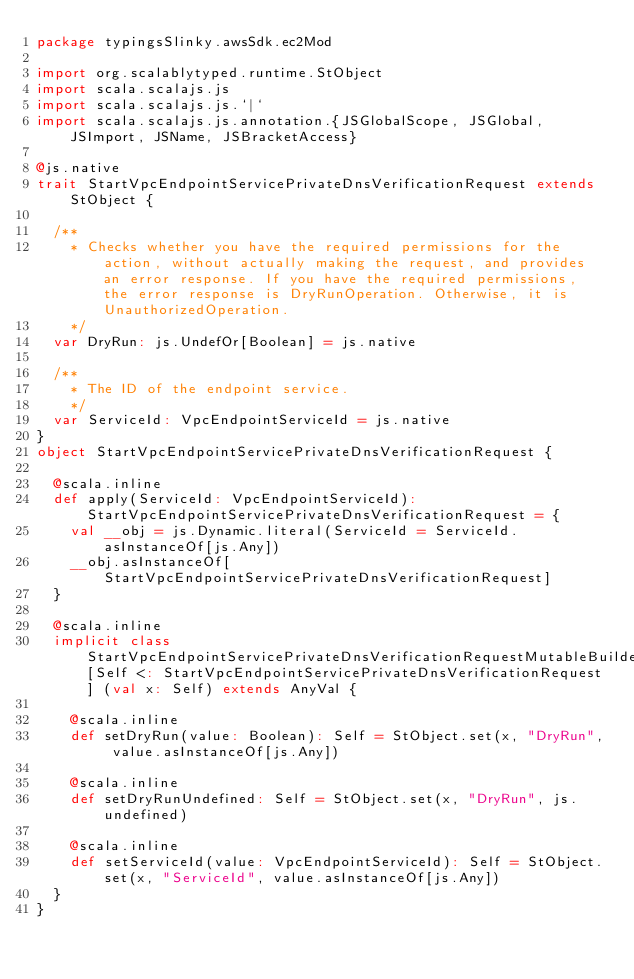<code> <loc_0><loc_0><loc_500><loc_500><_Scala_>package typingsSlinky.awsSdk.ec2Mod

import org.scalablytyped.runtime.StObject
import scala.scalajs.js
import scala.scalajs.js.`|`
import scala.scalajs.js.annotation.{JSGlobalScope, JSGlobal, JSImport, JSName, JSBracketAccess}

@js.native
trait StartVpcEndpointServicePrivateDnsVerificationRequest extends StObject {
  
  /**
    * Checks whether you have the required permissions for the action, without actually making the request, and provides an error response. If you have the required permissions, the error response is DryRunOperation. Otherwise, it is UnauthorizedOperation.
    */
  var DryRun: js.UndefOr[Boolean] = js.native
  
  /**
    * The ID of the endpoint service.
    */
  var ServiceId: VpcEndpointServiceId = js.native
}
object StartVpcEndpointServicePrivateDnsVerificationRequest {
  
  @scala.inline
  def apply(ServiceId: VpcEndpointServiceId): StartVpcEndpointServicePrivateDnsVerificationRequest = {
    val __obj = js.Dynamic.literal(ServiceId = ServiceId.asInstanceOf[js.Any])
    __obj.asInstanceOf[StartVpcEndpointServicePrivateDnsVerificationRequest]
  }
  
  @scala.inline
  implicit class StartVpcEndpointServicePrivateDnsVerificationRequestMutableBuilder[Self <: StartVpcEndpointServicePrivateDnsVerificationRequest] (val x: Self) extends AnyVal {
    
    @scala.inline
    def setDryRun(value: Boolean): Self = StObject.set(x, "DryRun", value.asInstanceOf[js.Any])
    
    @scala.inline
    def setDryRunUndefined: Self = StObject.set(x, "DryRun", js.undefined)
    
    @scala.inline
    def setServiceId(value: VpcEndpointServiceId): Self = StObject.set(x, "ServiceId", value.asInstanceOf[js.Any])
  }
}
</code> 